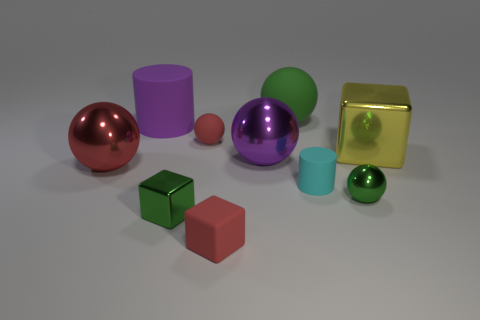There is a large metallic object in front of the large purple metallic ball; is it the same color as the rubber thing that is in front of the small green sphere?
Your answer should be very brief. Yes. Is the shape of the tiny green shiny object on the right side of the small red rubber block the same as the large purple thing that is left of the small green shiny block?
Provide a succinct answer. No. There is a yellow metallic object; what shape is it?
Your answer should be compact. Cube. There is a green object that is in front of the large red metallic sphere and right of the tiny red matte block; what is its shape?
Provide a short and direct response. Sphere. What color is the block that is the same material as the large cylinder?
Offer a terse response. Red. What is the shape of the tiny red rubber object that is behind the green object that is on the left side of the small matte thing that is behind the large yellow metal cube?
Give a very brief answer. Sphere. The green rubber ball is what size?
Give a very brief answer. Large. The green object that is the same material as the tiny cyan cylinder is what shape?
Offer a very short reply. Sphere. Is the number of cylinders behind the large purple metal sphere less than the number of tiny metallic objects?
Your answer should be compact. Yes. There is a ball that is to the right of the big green matte ball; what color is it?
Keep it short and to the point. Green. 